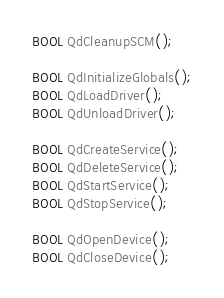<code> <loc_0><loc_0><loc_500><loc_500><_C_>BOOL QdCleanupSCM();

BOOL QdInitializeGlobals();
BOOL QdLoadDriver();
BOOL QdUnloadDriver();

BOOL QdCreateService();
BOOL QdDeleteService();
BOOL QdStartService();
BOOL QdStopService();

BOOL QdOpenDevice();
BOOL QdCloseDevice();
</code> 